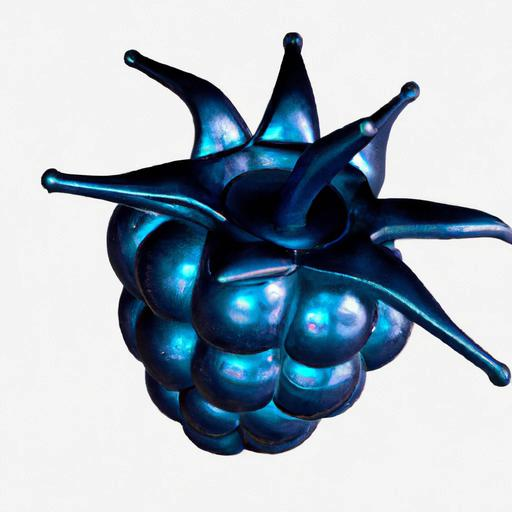Does this object have a practical function? It's difficult to ascertain the practical function of the object from the image alone, as it appears to be more artistic in nature. It could be a decorative piece meant to imitate a fruit-like form or an abstract sculpture. Could it be an item of jewelry or a household ornament? Yes, it certainly could be. Its aesthetic appeal and the detailed craftsmanship suggest that it might be designed as an item of jewelry, like a brooch or pendant, or a small, eye-catching household ornament placed on display. 